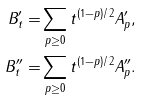<formula> <loc_0><loc_0><loc_500><loc_500>B ^ { \prime } _ { t } = & \sum _ { p \geq 0 } t ^ { ( 1 - p ) / 2 } A ^ { \prime } _ { p } , \\ B ^ { \prime \prime } _ { t } = & \sum _ { p \geq 0 } t ^ { ( 1 - p ) / 2 } A ^ { \prime \prime } _ { p } .</formula> 